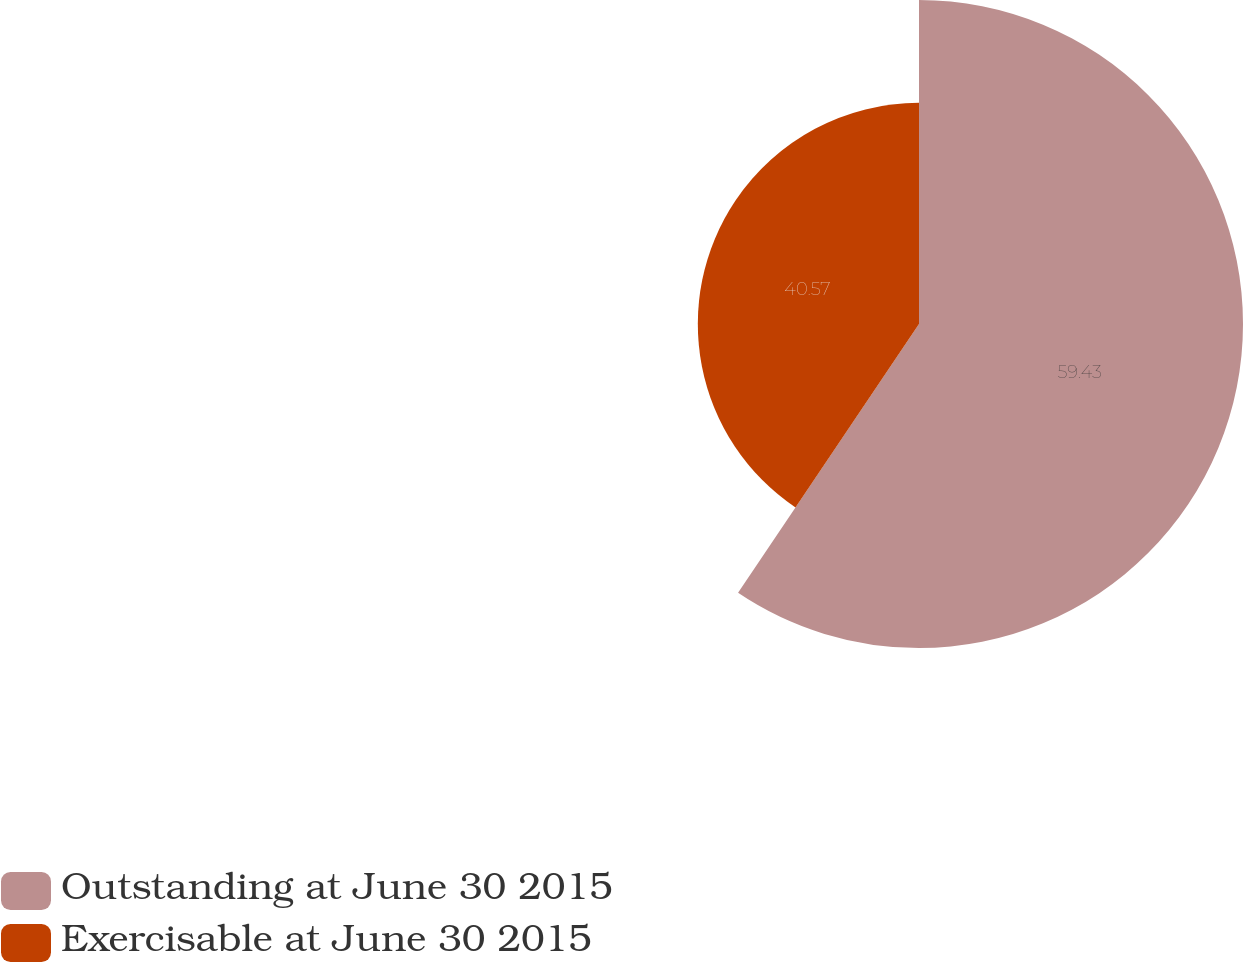Convert chart. <chart><loc_0><loc_0><loc_500><loc_500><pie_chart><fcel>Outstanding at June 30 2015<fcel>Exercisable at June 30 2015<nl><fcel>59.43%<fcel>40.57%<nl></chart> 